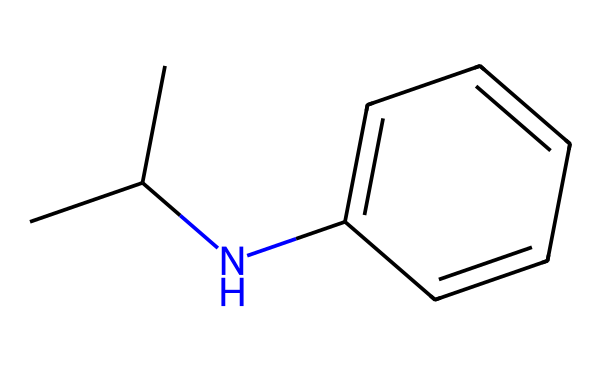What is the molecular formula of this compound? To find the molecular formula, count the number of each type of atom in the SMILES representation. The representation includes 10 carbons (C), 15 hydrogens (H), and 1 nitrogen (N), leading to the formula C10H15N.
Answer: C10H15N How many rings are present in the structure? Analyzing the structure from the SMILES, the "C1" and "C" later in the representation indicate the presence of a ring. There is one ring depicted in the structure.
Answer: 1 What functional group is featured in this compound? The amine group (-NH) derived from the nitrogen atom indicates that this compound features an amine functional group.
Answer: amine What is the primary psychoactive effect of methamphetamine on the brain? Methamphetamine is primarily known for its stimulating effect, enhancing the release of dopamine in the brain.
Answer: stimulation Which substituent contributes to the drug-like properties of this compound? The isopropyl group (CC(C)) attached to the nitrogen is a key substituent that affects the compound's pharmacological activities and enhances its lipophilicity.
Answer: isopropyl What type of drug is methamphetamine classified as? Methamphetamine is classified as a central nervous system stimulant, which is determined by its structure and effects on neurotransmitter levels.
Answer: stimulant 